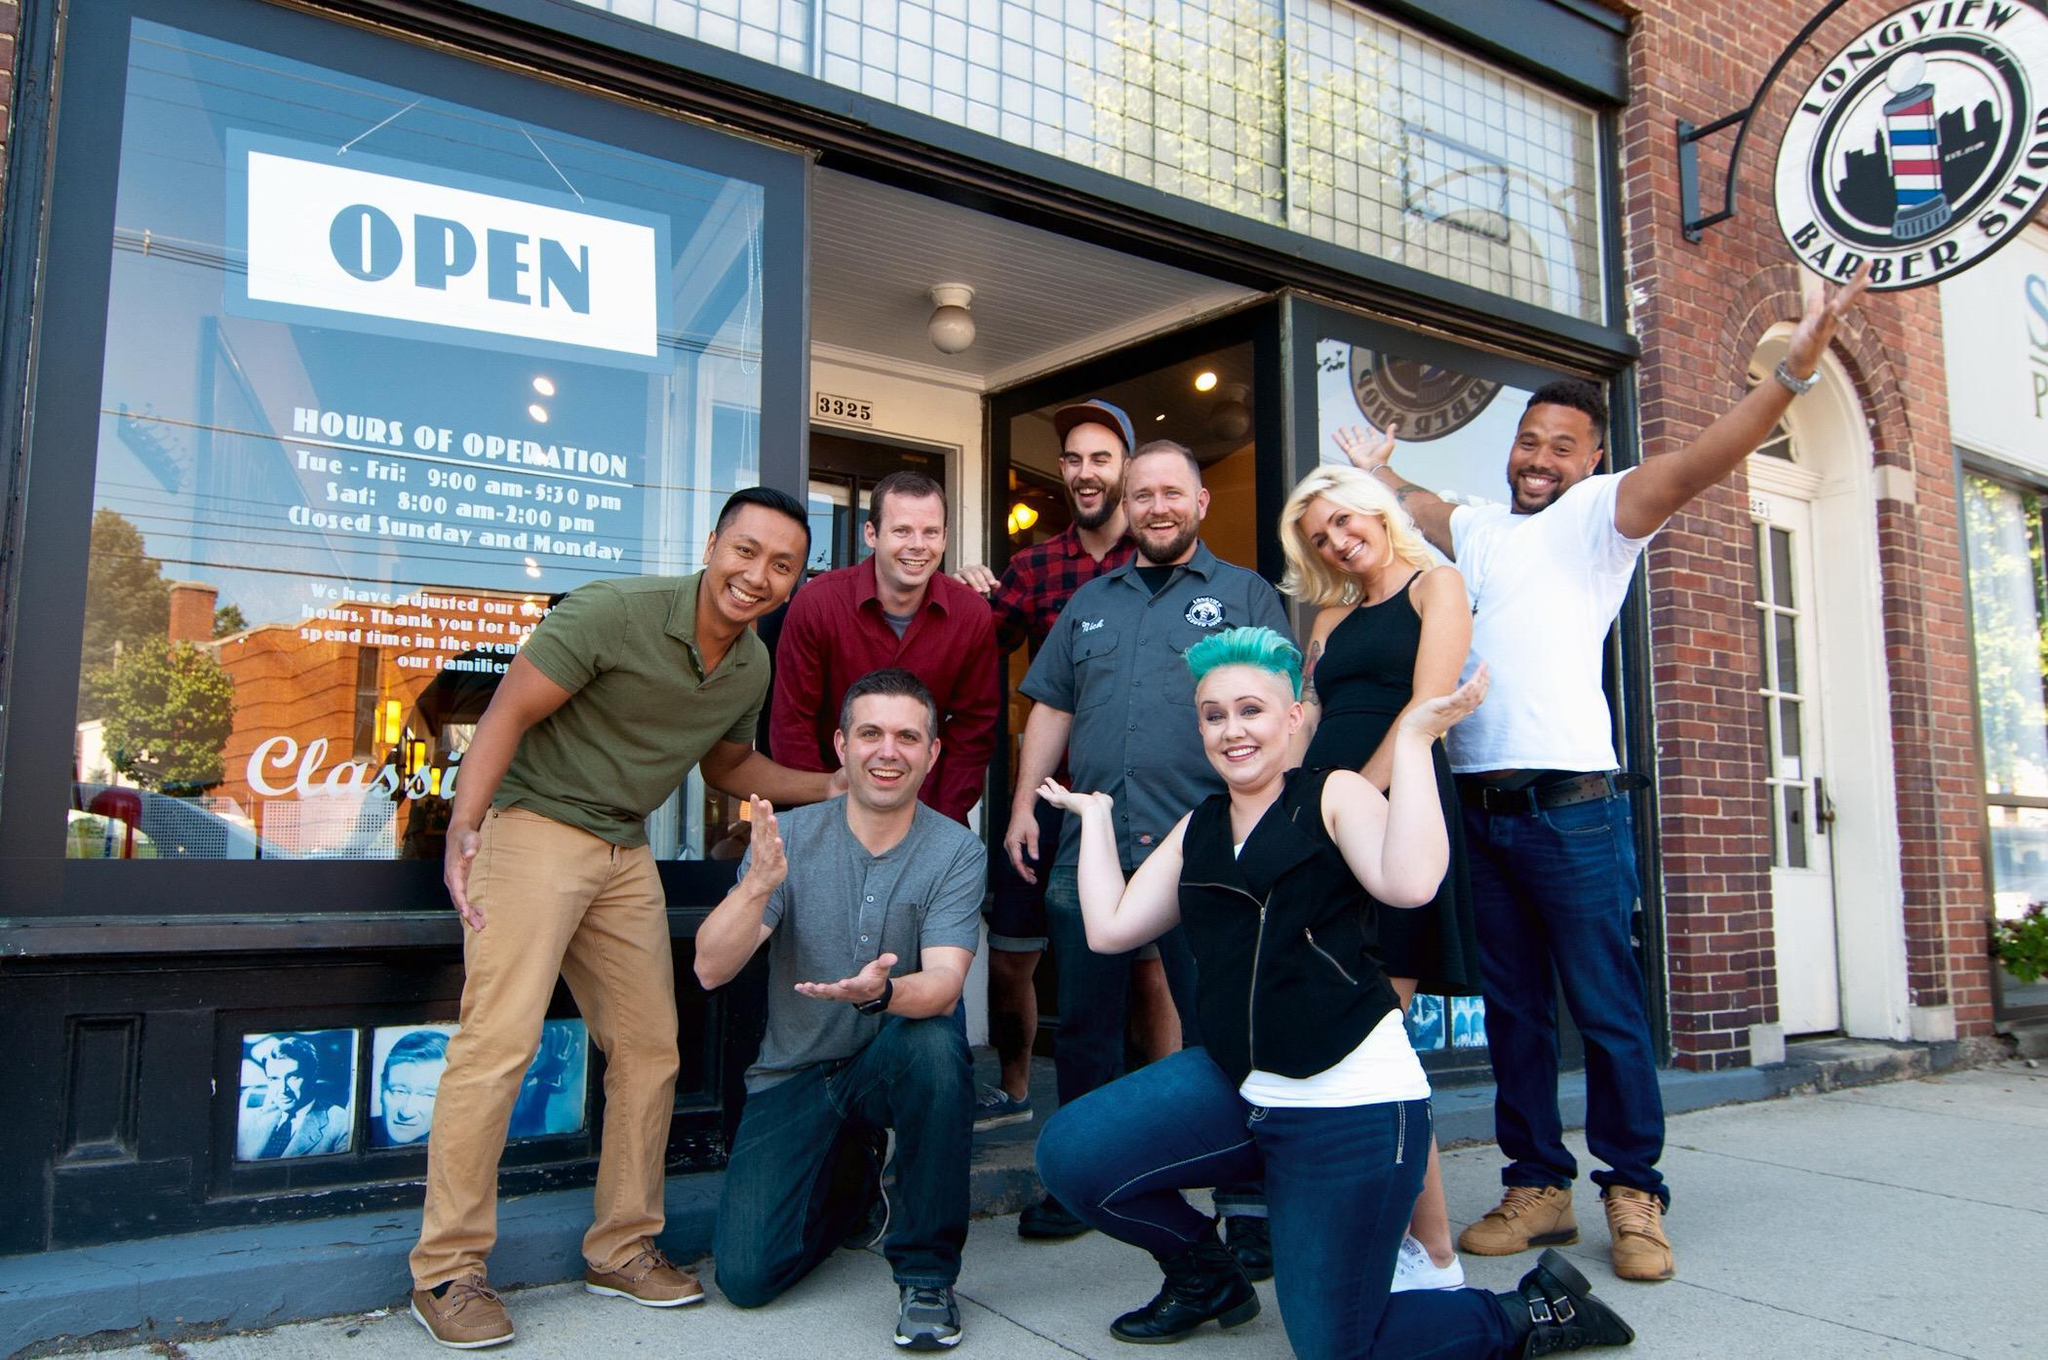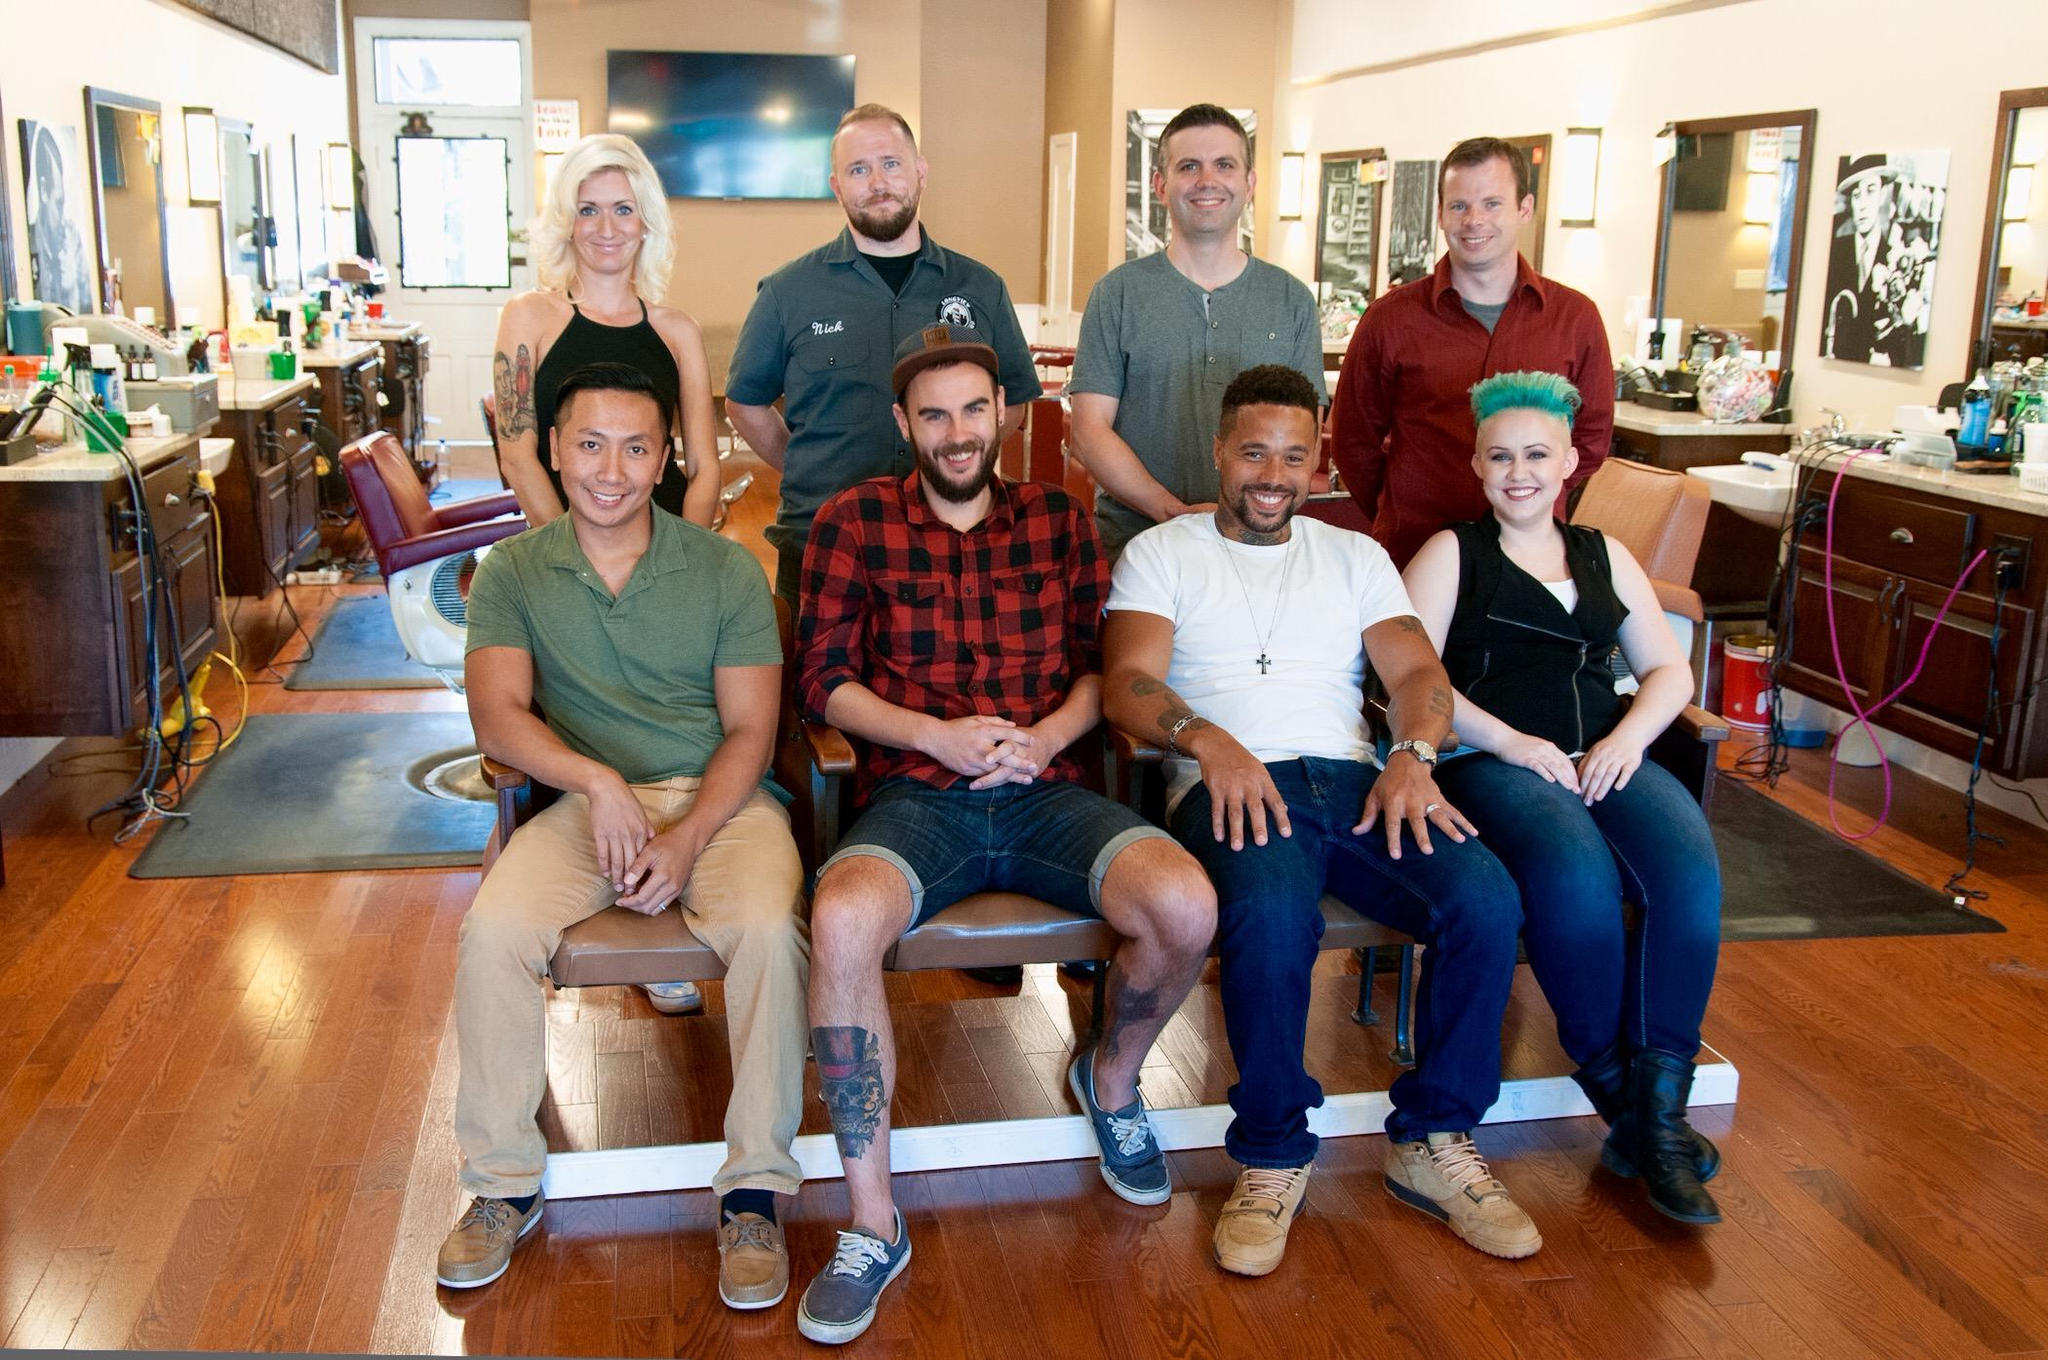The first image is the image on the left, the second image is the image on the right. For the images shown, is this caption "The left and right image contains a total of four men in a barber shop." true? Answer yes or no. No. 